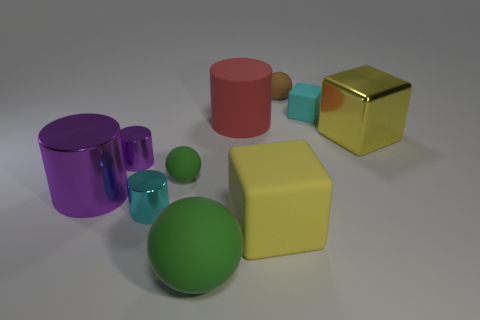What is the shape of the rubber object that is the same color as the large ball? sphere 